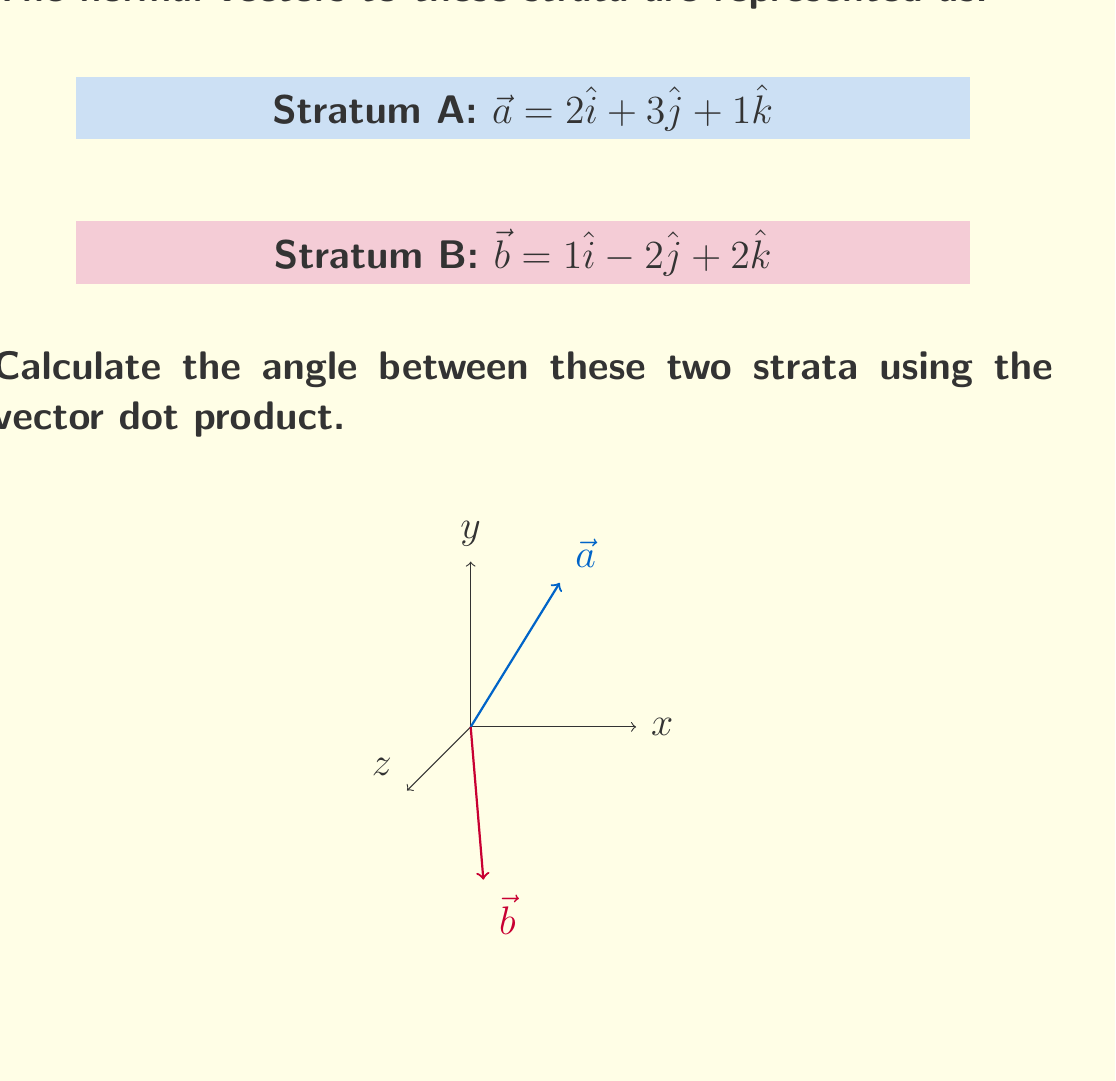Teach me how to tackle this problem. To find the angle between two vectors using the dot product, we can use the formula:

$$\cos \theta = \frac{\vec{a} \cdot \vec{b}}{|\vec{a}||\vec{b}|}$$

Where $\theta$ is the angle between the vectors, $\vec{a} \cdot \vec{b}$ is the dot product, and $|\vec{a}|$ and $|\vec{b}|$ are the magnitudes of the vectors.

Step 1: Calculate the dot product $\vec{a} \cdot \vec{b}$
$$\vec{a} \cdot \vec{b} = (2)(1) + (3)(-2) + (1)(2) = 2 - 6 + 2 = -2$$

Step 2: Calculate the magnitudes of $\vec{a}$ and $\vec{b}$
$$|\vec{a}| = \sqrt{2^2 + 3^2 + 1^2} = \sqrt{14}$$
$$|\vec{b}| = \sqrt{1^2 + (-2)^2 + 2^2} = 3$$

Step 3: Apply the formula
$$\cos \theta = \frac{-2}{\sqrt{14} \cdot 3} = -\frac{2}{3\sqrt{14}}$$

Step 4: Take the inverse cosine (arccos) of both sides
$$\theta = \arccos\left(-\frac{2}{3\sqrt{14}}\right)$$

Step 5: Convert to degrees
$$\theta = \arccos\left(-\frac{2}{3\sqrt{14}}\right) \cdot \frac{180°}{\pi} \approx 101.54°$$
Answer: $101.54°$ 